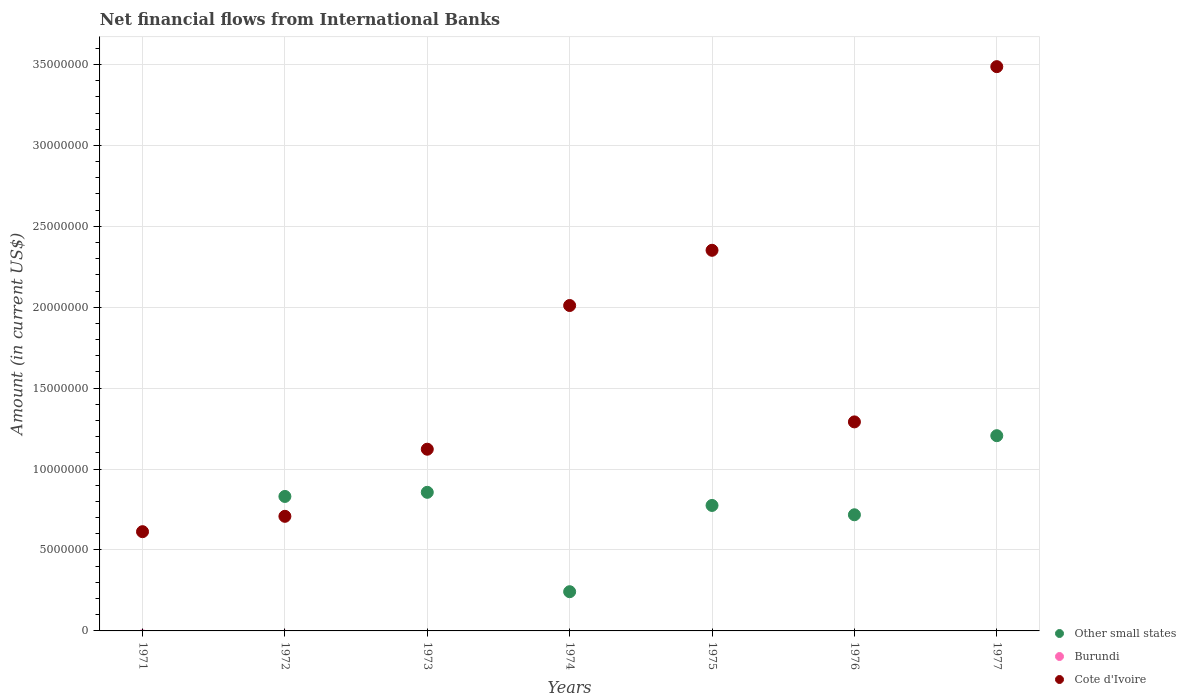Across all years, what is the maximum net financial aid flows in Cote d'Ivoire?
Keep it short and to the point. 3.49e+07. What is the total net financial aid flows in Burundi in the graph?
Your answer should be very brief. 0. What is the difference between the net financial aid flows in Cote d'Ivoire in 1974 and that in 1975?
Your answer should be compact. -3.41e+06. What is the difference between the net financial aid flows in Burundi in 1973 and the net financial aid flows in Other small states in 1974?
Keep it short and to the point. -2.42e+06. What is the average net financial aid flows in Cote d'Ivoire per year?
Your answer should be compact. 1.65e+07. In the year 1976, what is the difference between the net financial aid flows in Other small states and net financial aid flows in Cote d'Ivoire?
Make the answer very short. -5.74e+06. What is the ratio of the net financial aid flows in Cote d'Ivoire in 1972 to that in 1973?
Offer a terse response. 0.63. What is the difference between the highest and the second highest net financial aid flows in Cote d'Ivoire?
Provide a succinct answer. 1.13e+07. What is the difference between the highest and the lowest net financial aid flows in Other small states?
Provide a short and direct response. 1.21e+07. What is the difference between two consecutive major ticks on the Y-axis?
Keep it short and to the point. 5.00e+06. Does the graph contain any zero values?
Offer a very short reply. Yes. Does the graph contain grids?
Make the answer very short. Yes. How many legend labels are there?
Provide a succinct answer. 3. What is the title of the graph?
Provide a short and direct response. Net financial flows from International Banks. What is the label or title of the Y-axis?
Your answer should be compact. Amount (in current US$). What is the Amount (in current US$) in Other small states in 1971?
Make the answer very short. 0. What is the Amount (in current US$) of Cote d'Ivoire in 1971?
Keep it short and to the point. 6.13e+06. What is the Amount (in current US$) in Other small states in 1972?
Your answer should be very brief. 8.31e+06. What is the Amount (in current US$) in Cote d'Ivoire in 1972?
Provide a short and direct response. 7.08e+06. What is the Amount (in current US$) of Other small states in 1973?
Your answer should be compact. 8.56e+06. What is the Amount (in current US$) of Burundi in 1973?
Ensure brevity in your answer.  0. What is the Amount (in current US$) of Cote d'Ivoire in 1973?
Offer a terse response. 1.12e+07. What is the Amount (in current US$) of Other small states in 1974?
Provide a short and direct response. 2.42e+06. What is the Amount (in current US$) of Cote d'Ivoire in 1974?
Ensure brevity in your answer.  2.01e+07. What is the Amount (in current US$) in Other small states in 1975?
Offer a terse response. 7.75e+06. What is the Amount (in current US$) of Burundi in 1975?
Provide a succinct answer. 0. What is the Amount (in current US$) in Cote d'Ivoire in 1975?
Your response must be concise. 2.35e+07. What is the Amount (in current US$) in Other small states in 1976?
Offer a terse response. 7.18e+06. What is the Amount (in current US$) of Cote d'Ivoire in 1976?
Your response must be concise. 1.29e+07. What is the Amount (in current US$) of Other small states in 1977?
Offer a very short reply. 1.21e+07. What is the Amount (in current US$) in Burundi in 1977?
Ensure brevity in your answer.  0. What is the Amount (in current US$) of Cote d'Ivoire in 1977?
Provide a short and direct response. 3.49e+07. Across all years, what is the maximum Amount (in current US$) in Other small states?
Provide a short and direct response. 1.21e+07. Across all years, what is the maximum Amount (in current US$) in Cote d'Ivoire?
Make the answer very short. 3.49e+07. Across all years, what is the minimum Amount (in current US$) in Other small states?
Your response must be concise. 0. Across all years, what is the minimum Amount (in current US$) of Cote d'Ivoire?
Your response must be concise. 6.13e+06. What is the total Amount (in current US$) in Other small states in the graph?
Keep it short and to the point. 4.63e+07. What is the total Amount (in current US$) in Cote d'Ivoire in the graph?
Offer a very short reply. 1.16e+08. What is the difference between the Amount (in current US$) in Cote d'Ivoire in 1971 and that in 1972?
Ensure brevity in your answer.  -9.49e+05. What is the difference between the Amount (in current US$) of Cote d'Ivoire in 1971 and that in 1973?
Provide a succinct answer. -5.10e+06. What is the difference between the Amount (in current US$) of Cote d'Ivoire in 1971 and that in 1974?
Make the answer very short. -1.40e+07. What is the difference between the Amount (in current US$) in Cote d'Ivoire in 1971 and that in 1975?
Provide a succinct answer. -1.74e+07. What is the difference between the Amount (in current US$) of Cote d'Ivoire in 1971 and that in 1976?
Provide a succinct answer. -6.78e+06. What is the difference between the Amount (in current US$) in Cote d'Ivoire in 1971 and that in 1977?
Keep it short and to the point. -2.87e+07. What is the difference between the Amount (in current US$) in Other small states in 1972 and that in 1973?
Provide a short and direct response. -2.55e+05. What is the difference between the Amount (in current US$) in Cote d'Ivoire in 1972 and that in 1973?
Your answer should be compact. -4.15e+06. What is the difference between the Amount (in current US$) in Other small states in 1972 and that in 1974?
Your answer should be very brief. 5.89e+06. What is the difference between the Amount (in current US$) of Cote d'Ivoire in 1972 and that in 1974?
Your response must be concise. -1.30e+07. What is the difference between the Amount (in current US$) in Other small states in 1972 and that in 1975?
Provide a short and direct response. 5.56e+05. What is the difference between the Amount (in current US$) of Cote d'Ivoire in 1972 and that in 1975?
Your response must be concise. -1.64e+07. What is the difference between the Amount (in current US$) of Other small states in 1972 and that in 1976?
Offer a very short reply. 1.13e+06. What is the difference between the Amount (in current US$) in Cote d'Ivoire in 1972 and that in 1976?
Ensure brevity in your answer.  -5.83e+06. What is the difference between the Amount (in current US$) of Other small states in 1972 and that in 1977?
Provide a short and direct response. -3.75e+06. What is the difference between the Amount (in current US$) of Cote d'Ivoire in 1972 and that in 1977?
Offer a terse response. -2.78e+07. What is the difference between the Amount (in current US$) in Other small states in 1973 and that in 1974?
Your answer should be compact. 6.14e+06. What is the difference between the Amount (in current US$) in Cote d'Ivoire in 1973 and that in 1974?
Give a very brief answer. -8.88e+06. What is the difference between the Amount (in current US$) of Other small states in 1973 and that in 1975?
Make the answer very short. 8.11e+05. What is the difference between the Amount (in current US$) in Cote d'Ivoire in 1973 and that in 1975?
Your response must be concise. -1.23e+07. What is the difference between the Amount (in current US$) in Other small states in 1973 and that in 1976?
Offer a terse response. 1.39e+06. What is the difference between the Amount (in current US$) of Cote d'Ivoire in 1973 and that in 1976?
Offer a very short reply. -1.69e+06. What is the difference between the Amount (in current US$) in Other small states in 1973 and that in 1977?
Offer a terse response. -3.50e+06. What is the difference between the Amount (in current US$) in Cote d'Ivoire in 1973 and that in 1977?
Offer a very short reply. -2.36e+07. What is the difference between the Amount (in current US$) of Other small states in 1974 and that in 1975?
Provide a short and direct response. -5.33e+06. What is the difference between the Amount (in current US$) in Cote d'Ivoire in 1974 and that in 1975?
Provide a succinct answer. -3.41e+06. What is the difference between the Amount (in current US$) in Other small states in 1974 and that in 1976?
Keep it short and to the point. -4.75e+06. What is the difference between the Amount (in current US$) of Cote d'Ivoire in 1974 and that in 1976?
Offer a terse response. 7.19e+06. What is the difference between the Amount (in current US$) in Other small states in 1974 and that in 1977?
Ensure brevity in your answer.  -9.64e+06. What is the difference between the Amount (in current US$) in Cote d'Ivoire in 1974 and that in 1977?
Ensure brevity in your answer.  -1.48e+07. What is the difference between the Amount (in current US$) in Other small states in 1975 and that in 1976?
Ensure brevity in your answer.  5.77e+05. What is the difference between the Amount (in current US$) of Cote d'Ivoire in 1975 and that in 1976?
Ensure brevity in your answer.  1.06e+07. What is the difference between the Amount (in current US$) of Other small states in 1975 and that in 1977?
Ensure brevity in your answer.  -4.31e+06. What is the difference between the Amount (in current US$) in Cote d'Ivoire in 1975 and that in 1977?
Ensure brevity in your answer.  -1.13e+07. What is the difference between the Amount (in current US$) of Other small states in 1976 and that in 1977?
Make the answer very short. -4.89e+06. What is the difference between the Amount (in current US$) of Cote d'Ivoire in 1976 and that in 1977?
Keep it short and to the point. -2.20e+07. What is the difference between the Amount (in current US$) of Other small states in 1972 and the Amount (in current US$) of Cote d'Ivoire in 1973?
Your answer should be very brief. -2.92e+06. What is the difference between the Amount (in current US$) of Other small states in 1972 and the Amount (in current US$) of Cote d'Ivoire in 1974?
Make the answer very short. -1.18e+07. What is the difference between the Amount (in current US$) of Other small states in 1972 and the Amount (in current US$) of Cote d'Ivoire in 1975?
Your answer should be compact. -1.52e+07. What is the difference between the Amount (in current US$) of Other small states in 1972 and the Amount (in current US$) of Cote d'Ivoire in 1976?
Your answer should be very brief. -4.61e+06. What is the difference between the Amount (in current US$) of Other small states in 1972 and the Amount (in current US$) of Cote d'Ivoire in 1977?
Keep it short and to the point. -2.66e+07. What is the difference between the Amount (in current US$) in Other small states in 1973 and the Amount (in current US$) in Cote d'Ivoire in 1974?
Give a very brief answer. -1.15e+07. What is the difference between the Amount (in current US$) of Other small states in 1973 and the Amount (in current US$) of Cote d'Ivoire in 1975?
Provide a succinct answer. -1.50e+07. What is the difference between the Amount (in current US$) in Other small states in 1973 and the Amount (in current US$) in Cote d'Ivoire in 1976?
Your answer should be compact. -4.35e+06. What is the difference between the Amount (in current US$) in Other small states in 1973 and the Amount (in current US$) in Cote d'Ivoire in 1977?
Provide a short and direct response. -2.63e+07. What is the difference between the Amount (in current US$) of Other small states in 1974 and the Amount (in current US$) of Cote d'Ivoire in 1975?
Your answer should be compact. -2.11e+07. What is the difference between the Amount (in current US$) in Other small states in 1974 and the Amount (in current US$) in Cote d'Ivoire in 1976?
Give a very brief answer. -1.05e+07. What is the difference between the Amount (in current US$) of Other small states in 1974 and the Amount (in current US$) of Cote d'Ivoire in 1977?
Your answer should be compact. -3.24e+07. What is the difference between the Amount (in current US$) in Other small states in 1975 and the Amount (in current US$) in Cote d'Ivoire in 1976?
Keep it short and to the point. -5.16e+06. What is the difference between the Amount (in current US$) in Other small states in 1975 and the Amount (in current US$) in Cote d'Ivoire in 1977?
Give a very brief answer. -2.71e+07. What is the difference between the Amount (in current US$) of Other small states in 1976 and the Amount (in current US$) of Cote d'Ivoire in 1977?
Ensure brevity in your answer.  -2.77e+07. What is the average Amount (in current US$) in Other small states per year?
Your response must be concise. 6.61e+06. What is the average Amount (in current US$) of Cote d'Ivoire per year?
Offer a terse response. 1.65e+07. In the year 1972, what is the difference between the Amount (in current US$) in Other small states and Amount (in current US$) in Cote d'Ivoire?
Offer a very short reply. 1.23e+06. In the year 1973, what is the difference between the Amount (in current US$) in Other small states and Amount (in current US$) in Cote d'Ivoire?
Keep it short and to the point. -2.66e+06. In the year 1974, what is the difference between the Amount (in current US$) in Other small states and Amount (in current US$) in Cote d'Ivoire?
Your response must be concise. -1.77e+07. In the year 1975, what is the difference between the Amount (in current US$) in Other small states and Amount (in current US$) in Cote d'Ivoire?
Keep it short and to the point. -1.58e+07. In the year 1976, what is the difference between the Amount (in current US$) in Other small states and Amount (in current US$) in Cote d'Ivoire?
Keep it short and to the point. -5.74e+06. In the year 1977, what is the difference between the Amount (in current US$) in Other small states and Amount (in current US$) in Cote d'Ivoire?
Offer a terse response. -2.28e+07. What is the ratio of the Amount (in current US$) of Cote d'Ivoire in 1971 to that in 1972?
Your response must be concise. 0.87. What is the ratio of the Amount (in current US$) in Cote d'Ivoire in 1971 to that in 1973?
Your answer should be very brief. 0.55. What is the ratio of the Amount (in current US$) in Cote d'Ivoire in 1971 to that in 1974?
Offer a terse response. 0.3. What is the ratio of the Amount (in current US$) in Cote d'Ivoire in 1971 to that in 1975?
Ensure brevity in your answer.  0.26. What is the ratio of the Amount (in current US$) of Cote d'Ivoire in 1971 to that in 1976?
Your answer should be very brief. 0.47. What is the ratio of the Amount (in current US$) in Cote d'Ivoire in 1971 to that in 1977?
Give a very brief answer. 0.18. What is the ratio of the Amount (in current US$) of Other small states in 1972 to that in 1973?
Your response must be concise. 0.97. What is the ratio of the Amount (in current US$) of Cote d'Ivoire in 1972 to that in 1973?
Offer a very short reply. 0.63. What is the ratio of the Amount (in current US$) in Other small states in 1972 to that in 1974?
Give a very brief answer. 3.43. What is the ratio of the Amount (in current US$) of Cote d'Ivoire in 1972 to that in 1974?
Your answer should be very brief. 0.35. What is the ratio of the Amount (in current US$) of Other small states in 1972 to that in 1975?
Your answer should be very brief. 1.07. What is the ratio of the Amount (in current US$) in Cote d'Ivoire in 1972 to that in 1975?
Ensure brevity in your answer.  0.3. What is the ratio of the Amount (in current US$) of Other small states in 1972 to that in 1976?
Give a very brief answer. 1.16. What is the ratio of the Amount (in current US$) in Cote d'Ivoire in 1972 to that in 1976?
Provide a short and direct response. 0.55. What is the ratio of the Amount (in current US$) in Other small states in 1972 to that in 1977?
Offer a terse response. 0.69. What is the ratio of the Amount (in current US$) of Cote d'Ivoire in 1972 to that in 1977?
Offer a very short reply. 0.2. What is the ratio of the Amount (in current US$) in Other small states in 1973 to that in 1974?
Offer a terse response. 3.53. What is the ratio of the Amount (in current US$) of Cote d'Ivoire in 1973 to that in 1974?
Offer a terse response. 0.56. What is the ratio of the Amount (in current US$) in Other small states in 1973 to that in 1975?
Your response must be concise. 1.1. What is the ratio of the Amount (in current US$) in Cote d'Ivoire in 1973 to that in 1975?
Offer a very short reply. 0.48. What is the ratio of the Amount (in current US$) in Other small states in 1973 to that in 1976?
Give a very brief answer. 1.19. What is the ratio of the Amount (in current US$) of Cote d'Ivoire in 1973 to that in 1976?
Ensure brevity in your answer.  0.87. What is the ratio of the Amount (in current US$) in Other small states in 1973 to that in 1977?
Offer a terse response. 0.71. What is the ratio of the Amount (in current US$) of Cote d'Ivoire in 1973 to that in 1977?
Give a very brief answer. 0.32. What is the ratio of the Amount (in current US$) in Other small states in 1974 to that in 1975?
Your answer should be very brief. 0.31. What is the ratio of the Amount (in current US$) of Cote d'Ivoire in 1974 to that in 1975?
Provide a short and direct response. 0.85. What is the ratio of the Amount (in current US$) of Other small states in 1974 to that in 1976?
Provide a succinct answer. 0.34. What is the ratio of the Amount (in current US$) in Cote d'Ivoire in 1974 to that in 1976?
Ensure brevity in your answer.  1.56. What is the ratio of the Amount (in current US$) of Other small states in 1974 to that in 1977?
Your answer should be compact. 0.2. What is the ratio of the Amount (in current US$) of Cote d'Ivoire in 1974 to that in 1977?
Your answer should be very brief. 0.58. What is the ratio of the Amount (in current US$) of Other small states in 1975 to that in 1976?
Provide a short and direct response. 1.08. What is the ratio of the Amount (in current US$) in Cote d'Ivoire in 1975 to that in 1976?
Provide a short and direct response. 1.82. What is the ratio of the Amount (in current US$) in Other small states in 1975 to that in 1977?
Your answer should be very brief. 0.64. What is the ratio of the Amount (in current US$) of Cote d'Ivoire in 1975 to that in 1977?
Provide a succinct answer. 0.67. What is the ratio of the Amount (in current US$) of Other small states in 1976 to that in 1977?
Keep it short and to the point. 0.59. What is the ratio of the Amount (in current US$) of Cote d'Ivoire in 1976 to that in 1977?
Your response must be concise. 0.37. What is the difference between the highest and the second highest Amount (in current US$) of Other small states?
Make the answer very short. 3.50e+06. What is the difference between the highest and the second highest Amount (in current US$) of Cote d'Ivoire?
Your answer should be compact. 1.13e+07. What is the difference between the highest and the lowest Amount (in current US$) in Other small states?
Keep it short and to the point. 1.21e+07. What is the difference between the highest and the lowest Amount (in current US$) of Cote d'Ivoire?
Your answer should be very brief. 2.87e+07. 